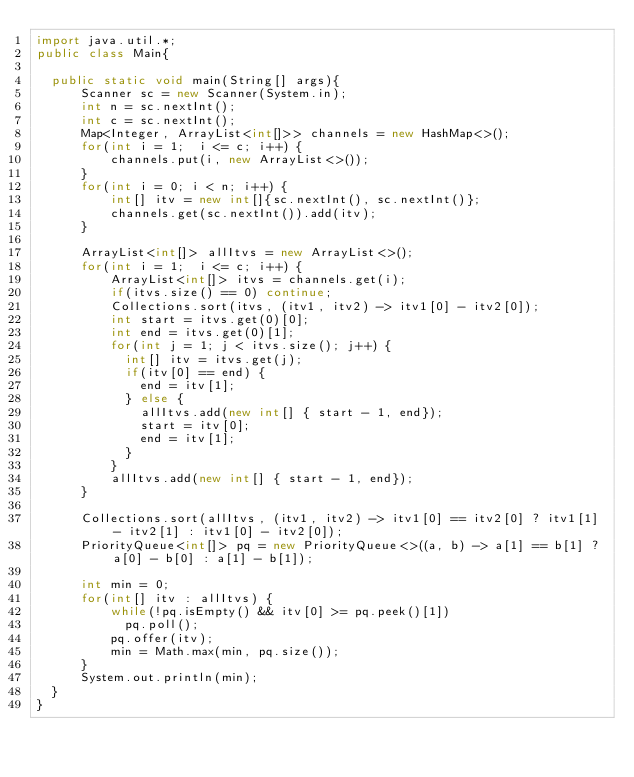Convert code to text. <code><loc_0><loc_0><loc_500><loc_500><_Java_>import java.util.*;
public class Main{

  public static void main(String[] args){
      Scanner sc = new Scanner(System.in);
      int n = sc.nextInt();
      int c = sc.nextInt();
      Map<Integer, ArrayList<int[]>> channels = new HashMap<>();
      for(int i = 1;  i <= c; i++) {
          channels.put(i, new ArrayList<>());
      }
      for(int i = 0; i < n; i++) {
          int[] itv = new int[]{sc.nextInt(), sc.nextInt()};
          channels.get(sc.nextInt()).add(itv);
      }

      ArrayList<int[]> allItvs = new ArrayList<>();
      for(int i = 1;  i <= c; i++) {
          ArrayList<int[]> itvs = channels.get(i);
          if(itvs.size() == 0) continue;
          Collections.sort(itvs, (itv1, itv2) -> itv1[0] - itv2[0]);
          int start = itvs.get(0)[0];
          int end = itvs.get(0)[1];
          for(int j = 1; j < itvs.size(); j++) {
            int[] itv = itvs.get(j);
            if(itv[0] == end) {
              end = itv[1];
            } else {
              allItvs.add(new int[] { start - 1, end});
              start = itv[0];
              end = itv[1];
            }
          }
          allItvs.add(new int[] { start - 1, end});
      }

      Collections.sort(allItvs, (itv1, itv2) -> itv1[0] == itv2[0] ? itv1[1] - itv2[1] : itv1[0] - itv2[0]);
      PriorityQueue<int[]> pq = new PriorityQueue<>((a, b) -> a[1] == b[1] ? a[0] - b[0] : a[1] - b[1]);

      int min = 0;
      for(int[] itv : allItvs) {
          while(!pq.isEmpty() && itv[0] >= pq.peek()[1])
            pq.poll();
          pq.offer(itv);
          min = Math.max(min, pq.size());
      }
      System.out.println(min);
  }
}

</code> 